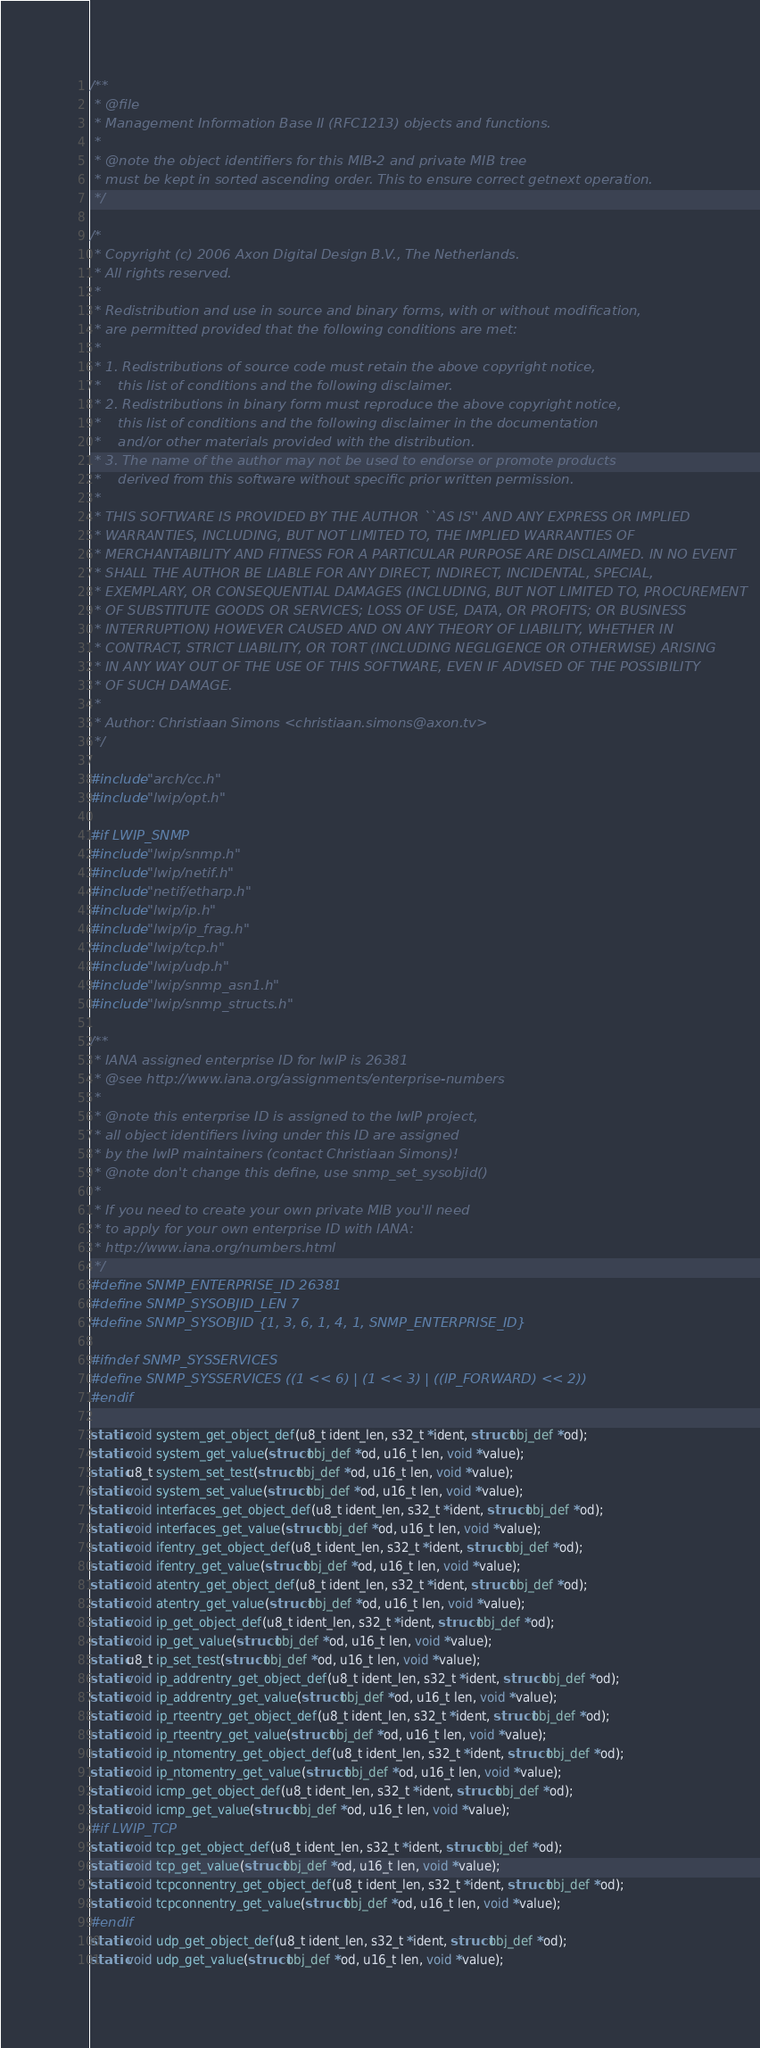<code> <loc_0><loc_0><loc_500><loc_500><_C_>/**
 * @file
 * Management Information Base II (RFC1213) objects and functions.
 *
 * @note the object identifiers for this MIB-2 and private MIB tree
 * must be kept in sorted ascending order. This to ensure correct getnext operation.
 */

/*
 * Copyright (c) 2006 Axon Digital Design B.V., The Netherlands.
 * All rights reserved.
 *
 * Redistribution and use in source and binary forms, with or without modification,
 * are permitted provided that the following conditions are met:
 *
 * 1. Redistributions of source code must retain the above copyright notice,
 *    this list of conditions and the following disclaimer.
 * 2. Redistributions in binary form must reproduce the above copyright notice,
 *    this list of conditions and the following disclaimer in the documentation
 *    and/or other materials provided with the distribution.
 * 3. The name of the author may not be used to endorse or promote products
 *    derived from this software without specific prior written permission.
 *
 * THIS SOFTWARE IS PROVIDED BY THE AUTHOR ``AS IS'' AND ANY EXPRESS OR IMPLIED
 * WARRANTIES, INCLUDING, BUT NOT LIMITED TO, THE IMPLIED WARRANTIES OF
 * MERCHANTABILITY AND FITNESS FOR A PARTICULAR PURPOSE ARE DISCLAIMED. IN NO EVENT
 * SHALL THE AUTHOR BE LIABLE FOR ANY DIRECT, INDIRECT, INCIDENTAL, SPECIAL,
 * EXEMPLARY, OR CONSEQUENTIAL DAMAGES (INCLUDING, BUT NOT LIMITED TO, PROCUREMENT
 * OF SUBSTITUTE GOODS OR SERVICES; LOSS OF USE, DATA, OR PROFITS; OR BUSINESS
 * INTERRUPTION) HOWEVER CAUSED AND ON ANY THEORY OF LIABILITY, WHETHER IN
 * CONTRACT, STRICT LIABILITY, OR TORT (INCLUDING NEGLIGENCE OR OTHERWISE) ARISING
 * IN ANY WAY OUT OF THE USE OF THIS SOFTWARE, EVEN IF ADVISED OF THE POSSIBILITY
 * OF SUCH DAMAGE.
 *
 * Author: Christiaan Simons <christiaan.simons@axon.tv>
 */

#include "arch/cc.h"
#include "lwip/opt.h"

#if LWIP_SNMP
#include "lwip/snmp.h"
#include "lwip/netif.h"
#include "netif/etharp.h"
#include "lwip/ip.h"
#include "lwip/ip_frag.h"
#include "lwip/tcp.h"
#include "lwip/udp.h"
#include "lwip/snmp_asn1.h"
#include "lwip/snmp_structs.h"

/**
 * IANA assigned enterprise ID for lwIP is 26381
 * @see http://www.iana.org/assignments/enterprise-numbers
 *
 * @note this enterprise ID is assigned to the lwIP project,
 * all object identifiers living under this ID are assigned
 * by the lwIP maintainers (contact Christiaan Simons)!
 * @note don't change this define, use snmp_set_sysobjid()
 *
 * If you need to create your own private MIB you'll need
 * to apply for your own enterprise ID with IANA:
 * http://www.iana.org/numbers.html
 */
#define SNMP_ENTERPRISE_ID 26381
#define SNMP_SYSOBJID_LEN 7
#define SNMP_SYSOBJID {1, 3, 6, 1, 4, 1, SNMP_ENTERPRISE_ID}

#ifndef SNMP_SYSSERVICES
#define SNMP_SYSSERVICES ((1 << 6) | (1 << 3) | ((IP_FORWARD) << 2))
#endif

static void system_get_object_def(u8_t ident_len, s32_t *ident, struct obj_def *od);
static void system_get_value(struct obj_def *od, u16_t len, void *value);
static u8_t system_set_test(struct obj_def *od, u16_t len, void *value);
static void system_set_value(struct obj_def *od, u16_t len, void *value);
static void interfaces_get_object_def(u8_t ident_len, s32_t *ident, struct obj_def *od);
static void interfaces_get_value(struct obj_def *od, u16_t len, void *value);
static void ifentry_get_object_def(u8_t ident_len, s32_t *ident, struct obj_def *od);
static void ifentry_get_value(struct obj_def *od, u16_t len, void *value);
static void atentry_get_object_def(u8_t ident_len, s32_t *ident, struct obj_def *od);
static void atentry_get_value(struct obj_def *od, u16_t len, void *value);
static void ip_get_object_def(u8_t ident_len, s32_t *ident, struct obj_def *od);
static void ip_get_value(struct obj_def *od, u16_t len, void *value);
static u8_t ip_set_test(struct obj_def *od, u16_t len, void *value);
static void ip_addrentry_get_object_def(u8_t ident_len, s32_t *ident, struct obj_def *od);
static void ip_addrentry_get_value(struct obj_def *od, u16_t len, void *value);
static void ip_rteentry_get_object_def(u8_t ident_len, s32_t *ident, struct obj_def *od);
static void ip_rteentry_get_value(struct obj_def *od, u16_t len, void *value);
static void ip_ntomentry_get_object_def(u8_t ident_len, s32_t *ident, struct obj_def *od);
static void ip_ntomentry_get_value(struct obj_def *od, u16_t len, void *value);
static void icmp_get_object_def(u8_t ident_len, s32_t *ident, struct obj_def *od);
static void icmp_get_value(struct obj_def *od, u16_t len, void *value);
#if LWIP_TCP
static void tcp_get_object_def(u8_t ident_len, s32_t *ident, struct obj_def *od);
static void tcp_get_value(struct obj_def *od, u16_t len, void *value);
static void tcpconnentry_get_object_def(u8_t ident_len, s32_t *ident, struct obj_def *od);
static void tcpconnentry_get_value(struct obj_def *od, u16_t len, void *value);
#endif
static void udp_get_object_def(u8_t ident_len, s32_t *ident, struct obj_def *od);
static void udp_get_value(struct obj_def *od, u16_t len, void *value);</code> 